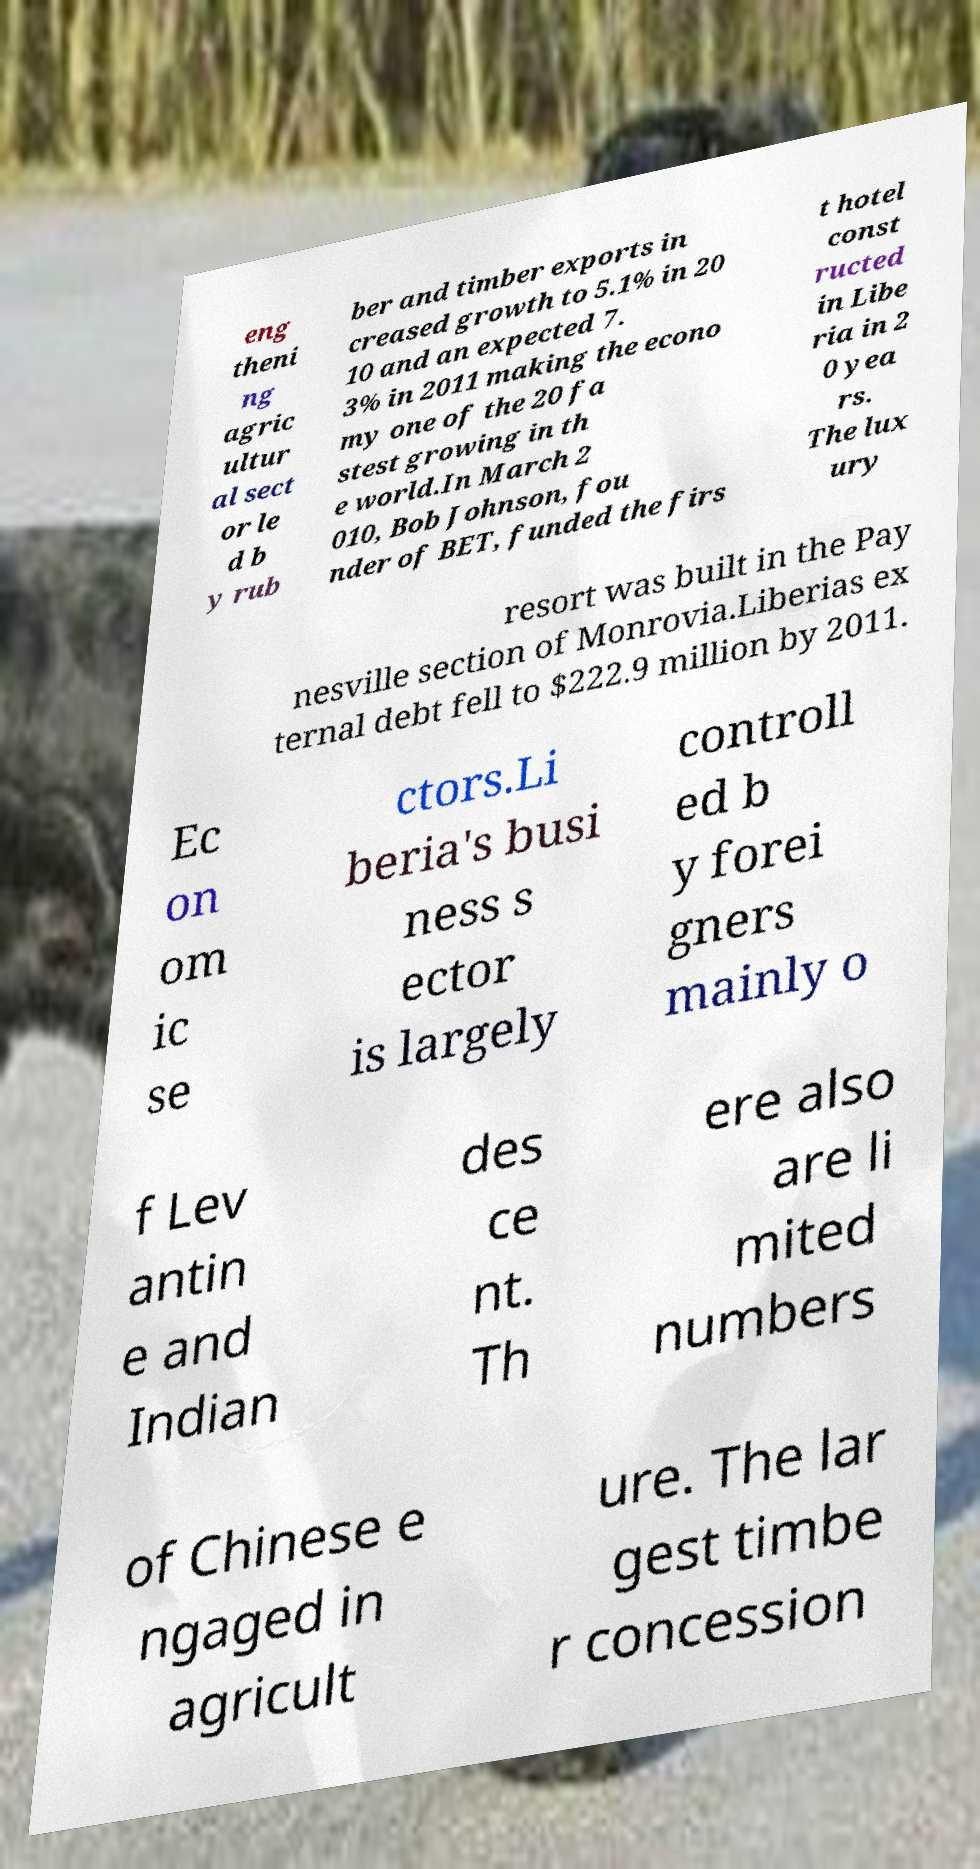Can you accurately transcribe the text from the provided image for me? eng theni ng agric ultur al sect or le d b y rub ber and timber exports in creased growth to 5.1% in 20 10 and an expected 7. 3% in 2011 making the econo my one of the 20 fa stest growing in th e world.In March 2 010, Bob Johnson, fou nder of BET, funded the firs t hotel const ructed in Libe ria in 2 0 yea rs. The lux ury resort was built in the Pay nesville section of Monrovia.Liberias ex ternal debt fell to $222.9 million by 2011. Ec on om ic se ctors.Li beria's busi ness s ector is largely controll ed b y forei gners mainly o f Lev antin e and Indian des ce nt. Th ere also are li mited numbers of Chinese e ngaged in agricult ure. The lar gest timbe r concession 